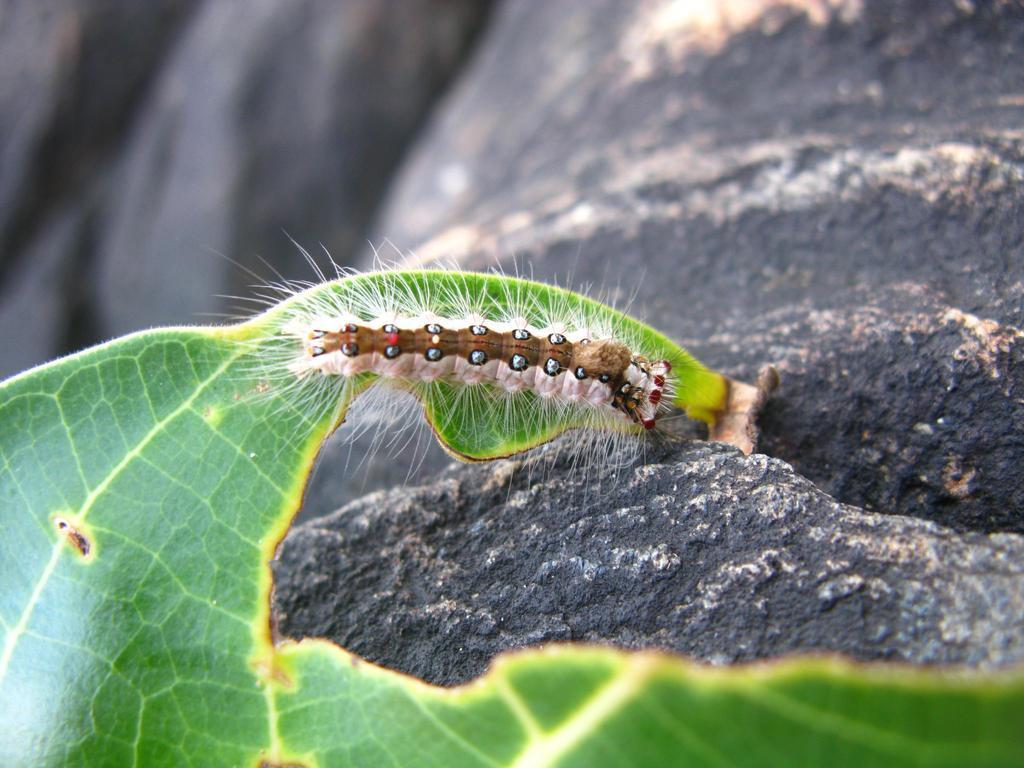How would you summarize this image in a sentence or two? In this picture we can see a caterpillar and a leaf in the front, in the background there is a rock. 